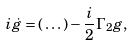Convert formula to latex. <formula><loc_0><loc_0><loc_500><loc_500>i \dot { g } = ( \, \dots ) - \frac { i } { 2 } \Gamma _ { 2 } g ,</formula> 